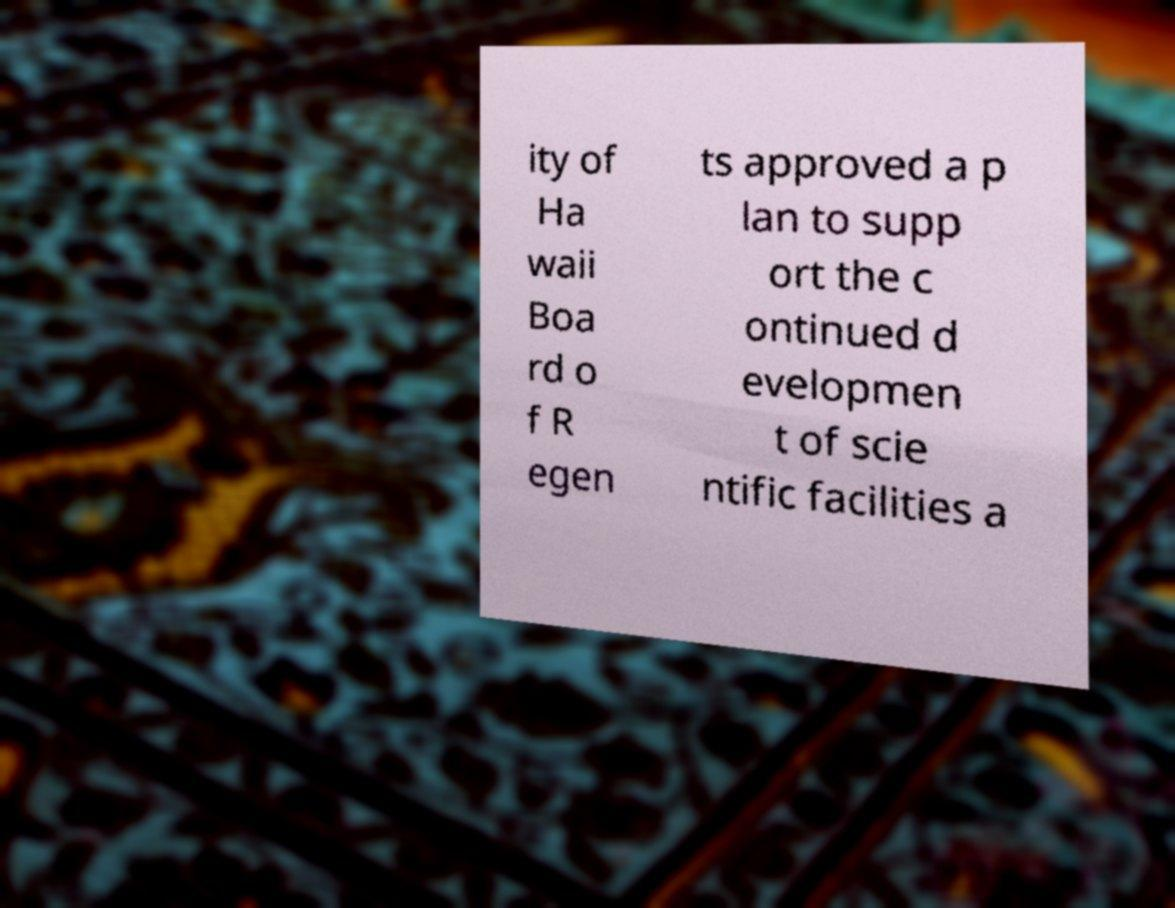Please identify and transcribe the text found in this image. ity of Ha waii Boa rd o f R egen ts approved a p lan to supp ort the c ontinued d evelopmen t of scie ntific facilities a 